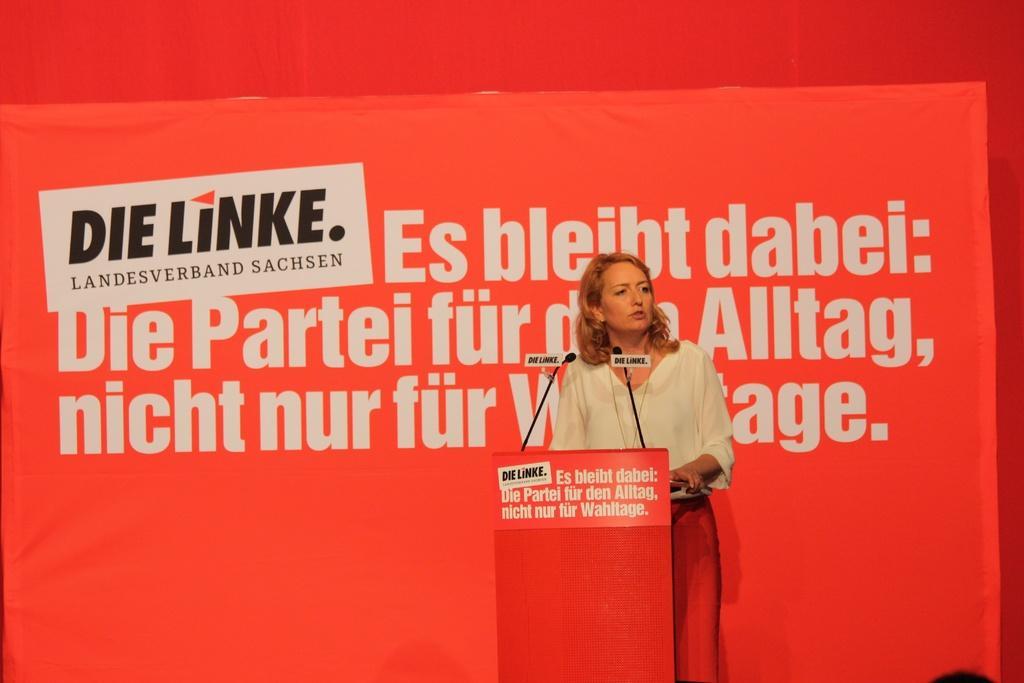Could you give a brief overview of what you see in this image? In this image I can see there is a woman standing behind the podium and there are microphones attached to the podium. In the backdrop there is a red color banner and there is something written on it. 